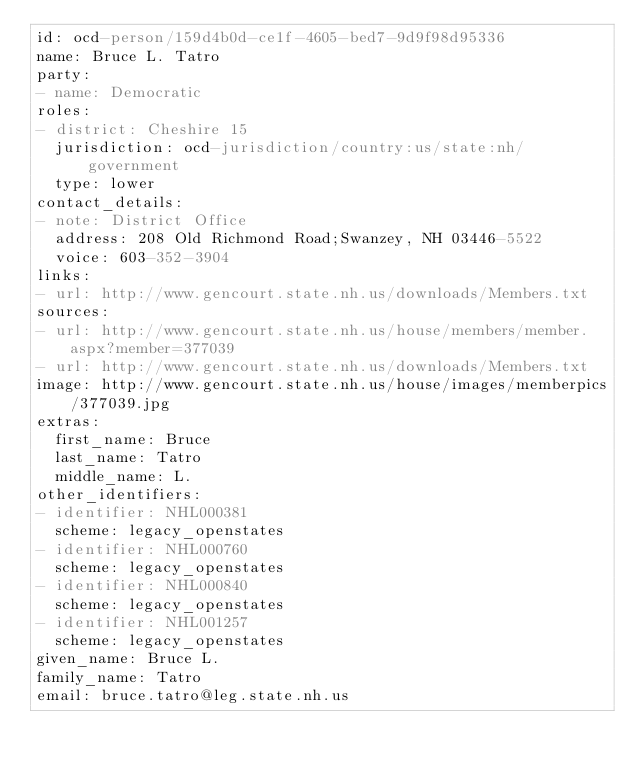Convert code to text. <code><loc_0><loc_0><loc_500><loc_500><_YAML_>id: ocd-person/159d4b0d-ce1f-4605-bed7-9d9f98d95336
name: Bruce L. Tatro
party:
- name: Democratic
roles:
- district: Cheshire 15
  jurisdiction: ocd-jurisdiction/country:us/state:nh/government
  type: lower
contact_details:
- note: District Office
  address: 208 Old Richmond Road;Swanzey, NH 03446-5522
  voice: 603-352-3904
links:
- url: http://www.gencourt.state.nh.us/downloads/Members.txt
sources:
- url: http://www.gencourt.state.nh.us/house/members/member.aspx?member=377039
- url: http://www.gencourt.state.nh.us/downloads/Members.txt
image: http://www.gencourt.state.nh.us/house/images/memberpics/377039.jpg
extras:
  first_name: Bruce
  last_name: Tatro
  middle_name: L.
other_identifiers:
- identifier: NHL000381
  scheme: legacy_openstates
- identifier: NHL000760
  scheme: legacy_openstates
- identifier: NHL000840
  scheme: legacy_openstates
- identifier: NHL001257
  scheme: legacy_openstates
given_name: Bruce L.
family_name: Tatro
email: bruce.tatro@leg.state.nh.us
</code> 